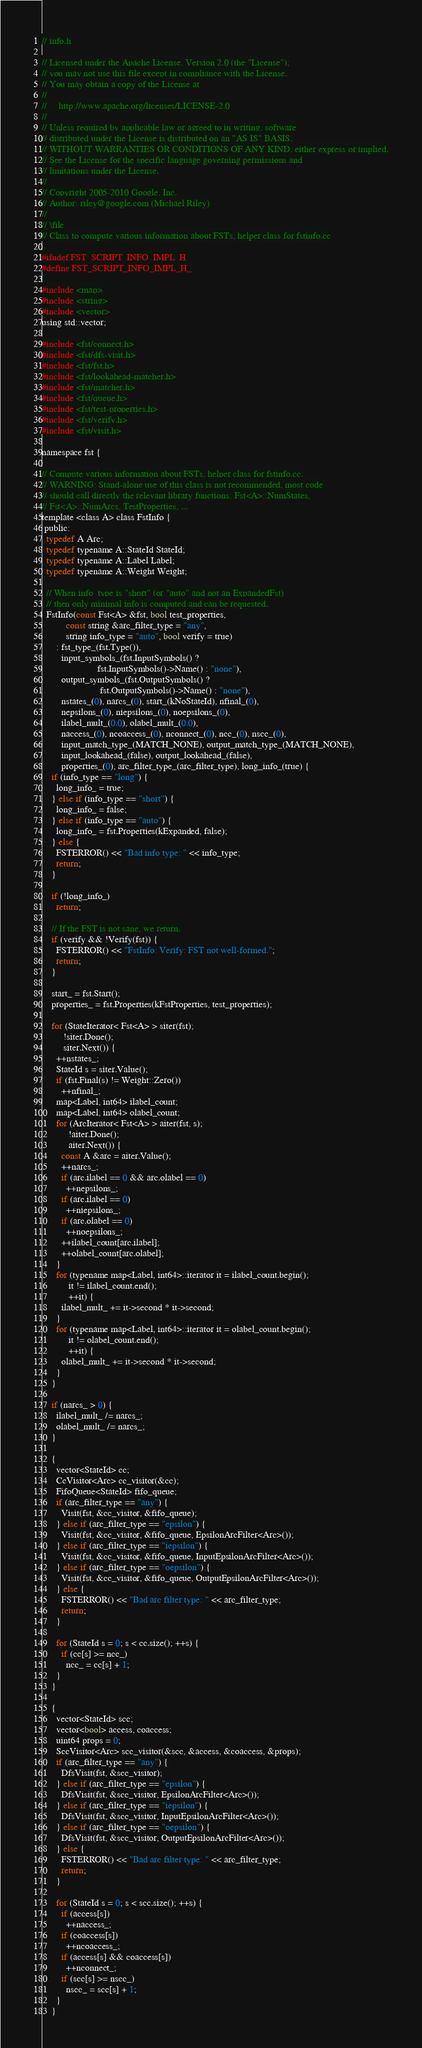Convert code to text. <code><loc_0><loc_0><loc_500><loc_500><_C_>// info.h

// Licensed under the Apache License, Version 2.0 (the "License");
// you may not use this file except in compliance with the License.
// You may obtain a copy of the License at
//
//     http://www.apache.org/licenses/LICENSE-2.0
//
// Unless required by applicable law or agreed to in writing, software
// distributed under the License is distributed on an "AS IS" BASIS,
// WITHOUT WARRANTIES OR CONDITIONS OF ANY KIND, either express or implied.
// See the License for the specific language governing permissions and
// limitations under the License.
//
// Copyright 2005-2010 Google, Inc.
// Author: riley@google.com (Michael Riley)
//
// \file
// Class to compute various information about FSTs, helper class for fstinfo.cc

#ifndef FST_SCRIPT_INFO_IMPL_H_
#define FST_SCRIPT_INFO_IMPL_H_

#include <map>
#include <string>
#include <vector>
using std::vector;

#include <fst/connect.h>
#include <fst/dfs-visit.h>
#include <fst/fst.h>
#include <fst/lookahead-matcher.h>
#include <fst/matcher.h>
#include <fst/queue.h>
#include <fst/test-properties.h>
#include <fst/verify.h>
#include <fst/visit.h>

namespace fst {

// Compute various information about FSTs, helper class for fstinfo.cc.
// WARNING: Stand-alone use of this class is not recommended, most code
// should call directly the relevant library functions: Fst<A>::NumStates,
// Fst<A>::NumArcs, TestProperties, ...
template <class A> class FstInfo {
 public:
  typedef A Arc;
  typedef typename A::StateId StateId;
  typedef typename A::Label Label;
  typedef typename A::Weight Weight;

  // When info_type is "short" (or "auto" and not an ExpandedFst)
  // then only minimal info is computed and can be requested.
  FstInfo(const Fst<A> &fst, bool test_properties,
          const string &arc_filter_type = "any",
          string info_type = "auto", bool verify = true)
      : fst_type_(fst.Type()),
        input_symbols_(fst.InputSymbols() ?
                       fst.InputSymbols()->Name() : "none"),
        output_symbols_(fst.OutputSymbols() ?
                        fst.OutputSymbols()->Name() : "none"),
        nstates_(0), narcs_(0), start_(kNoStateId), nfinal_(0),
        nepsilons_(0), niepsilons_(0), noepsilons_(0),
        ilabel_mult_(0.0), olabel_mult_(0.0),
        naccess_(0), ncoaccess_(0), nconnect_(0), ncc_(0), nscc_(0),
        input_match_type_(MATCH_NONE), output_match_type_(MATCH_NONE),
        input_lookahead_(false), output_lookahead_(false),
        properties_(0), arc_filter_type_(arc_filter_type), long_info_(true) {
    if (info_type == "long") {
      long_info_ = true;
    } else if (info_type == "short") {
      long_info_ = false;
    } else if (info_type == "auto") {
      long_info_ = fst.Properties(kExpanded, false);
    } else {
      FSTERROR() << "Bad info type: " << info_type;
      return;
    }

    if (!long_info_)
      return;

    // If the FST is not sane, we return.
    if (verify && !Verify(fst)) {
      FSTERROR() << "FstInfo: Verify: FST not well-formed.";
      return;
    }

    start_ = fst.Start();
    properties_ = fst.Properties(kFstProperties, test_properties);

    for (StateIterator< Fst<A> > siter(fst);
         !siter.Done();
         siter.Next()) {
      ++nstates_;
      StateId s = siter.Value();
      if (fst.Final(s) != Weight::Zero())
        ++nfinal_;
      map<Label, int64> ilabel_count;
      map<Label, int64> olabel_count;
      for (ArcIterator< Fst<A> > aiter(fst, s);
           !aiter.Done();
           aiter.Next()) {
        const A &arc = aiter.Value();
        ++narcs_;
        if (arc.ilabel == 0 && arc.olabel == 0)
          ++nepsilons_;
        if (arc.ilabel == 0)
          ++niepsilons_;
        if (arc.olabel == 0)
          ++noepsilons_;
        ++ilabel_count[arc.ilabel];
        ++olabel_count[arc.olabel];
      }
      for (typename map<Label, int64>::iterator it = ilabel_count.begin();
           it != ilabel_count.end();
           ++it) {
        ilabel_mult_ += it->second * it->second;
      }
      for (typename map<Label, int64>::iterator it = olabel_count.begin();
           it != olabel_count.end();
           ++it) {
        olabel_mult_ += it->second * it->second;
      }
    }

    if (narcs_ > 0) {
      ilabel_mult_ /= narcs_;
      olabel_mult_ /= narcs_;
    }

    {
      vector<StateId> cc;
      CcVisitor<Arc> cc_visitor(&cc);
      FifoQueue<StateId> fifo_queue;
      if (arc_filter_type == "any") {
        Visit(fst, &cc_visitor, &fifo_queue);
      } else if (arc_filter_type == "epsilon") {
        Visit(fst, &cc_visitor, &fifo_queue, EpsilonArcFilter<Arc>());
      } else if (arc_filter_type == "iepsilon") {
        Visit(fst, &cc_visitor, &fifo_queue, InputEpsilonArcFilter<Arc>());
      } else if (arc_filter_type == "oepsilon") {
        Visit(fst, &cc_visitor, &fifo_queue, OutputEpsilonArcFilter<Arc>());
      } else {
        FSTERROR() << "Bad arc filter type: " << arc_filter_type;
        return;
      }

      for (StateId s = 0; s < cc.size(); ++s) {
        if (cc[s] >= ncc_)
          ncc_ = cc[s] + 1;
      }
    }

    {
      vector<StateId> scc;
      vector<bool> access, coaccess;
      uint64 props = 0;
      SccVisitor<Arc> scc_visitor(&scc, &access, &coaccess, &props);
      if (arc_filter_type == "any") {
        DfsVisit(fst, &scc_visitor);
      } else if (arc_filter_type == "epsilon") {
        DfsVisit(fst, &scc_visitor, EpsilonArcFilter<Arc>());
      } else if (arc_filter_type == "iepsilon") {
        DfsVisit(fst, &scc_visitor, InputEpsilonArcFilter<Arc>());
      } else if (arc_filter_type == "oepsilon") {
        DfsVisit(fst, &scc_visitor, OutputEpsilonArcFilter<Arc>());
      } else {
        FSTERROR() << "Bad arc filter type: " << arc_filter_type;
        return;
      }

      for (StateId s = 0; s < scc.size(); ++s) {
        if (access[s])
          ++naccess_;
        if (coaccess[s])
          ++ncoaccess_;
        if (access[s] && coaccess[s])
          ++nconnect_;
        if (scc[s] >= nscc_)
          nscc_ = scc[s] + 1;
      }
    }
</code> 